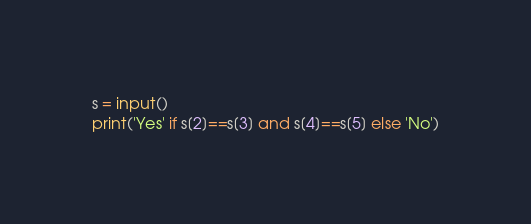Convert code to text. <code><loc_0><loc_0><loc_500><loc_500><_Python_>s = input()
print('Yes' if s[2]==s[3] and s[4]==s[5] else 'No')</code> 